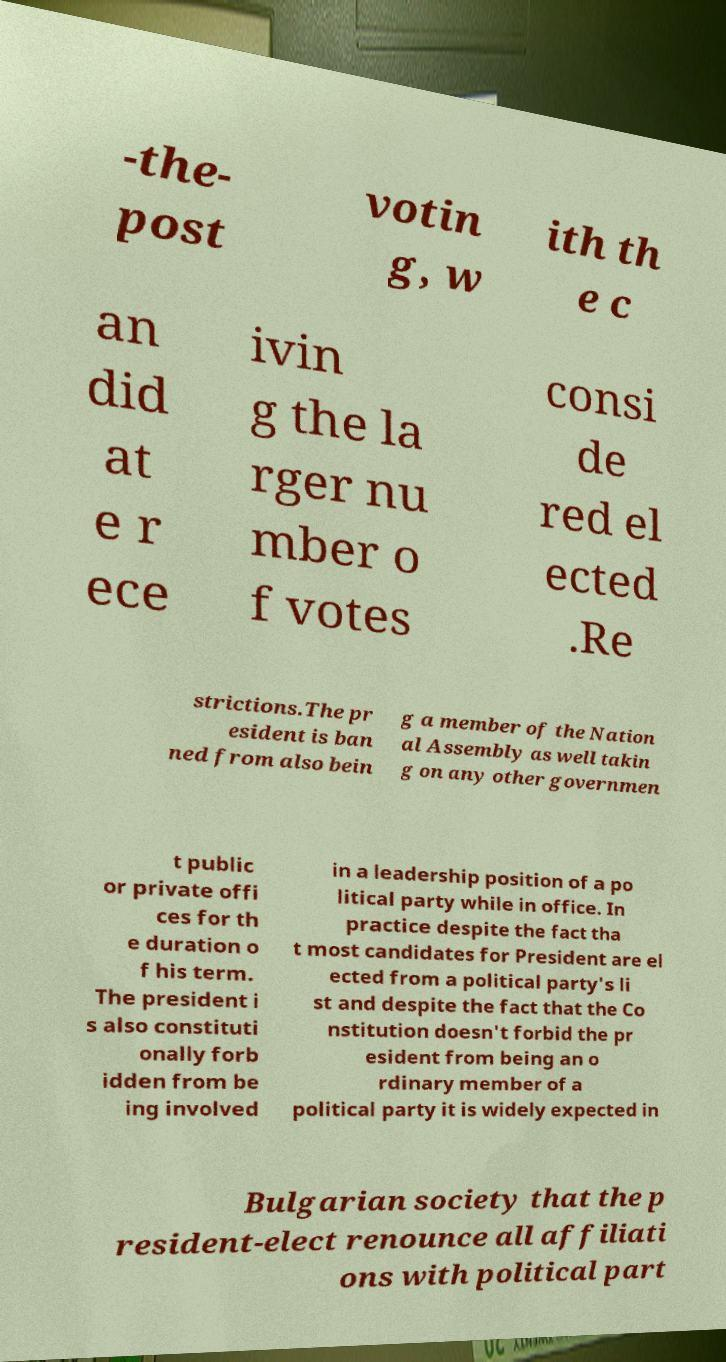Please read and relay the text visible in this image. What does it say? -the- post votin g, w ith th e c an did at e r ece ivin g the la rger nu mber o f votes consi de red el ected .Re strictions.The pr esident is ban ned from also bein g a member of the Nation al Assembly as well takin g on any other governmen t public or private offi ces for th e duration o f his term. The president i s also constituti onally forb idden from be ing involved in a leadership position of a po litical party while in office. In practice despite the fact tha t most candidates for President are el ected from a political party's li st and despite the fact that the Co nstitution doesn't forbid the pr esident from being an o rdinary member of a political party it is widely expected in Bulgarian society that the p resident-elect renounce all affiliati ons with political part 